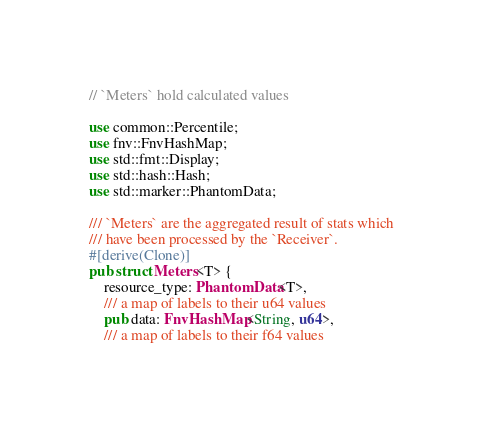Convert code to text. <code><loc_0><loc_0><loc_500><loc_500><_Rust_>// `Meters` hold calculated values

use common::Percentile;
use fnv::FnvHashMap;
use std::fmt::Display;
use std::hash::Hash;
use std::marker::PhantomData;

/// `Meters` are the aggregated result of stats which
/// have been processed by the `Receiver`.
#[derive(Clone)]
pub struct Meters<T> {
    resource_type: PhantomData<T>,
    /// a map of labels to their u64 values
    pub data: FnvHashMap<String, u64>,
    /// a map of labels to their f64 values</code> 